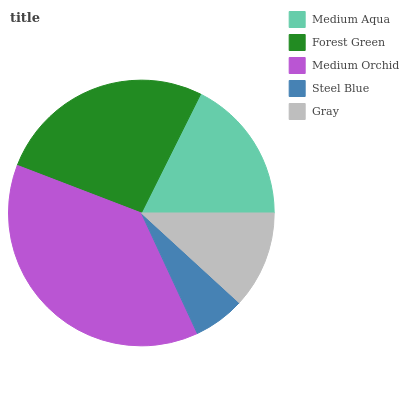Is Steel Blue the minimum?
Answer yes or no. Yes. Is Medium Orchid the maximum?
Answer yes or no. Yes. Is Forest Green the minimum?
Answer yes or no. No. Is Forest Green the maximum?
Answer yes or no. No. Is Forest Green greater than Medium Aqua?
Answer yes or no. Yes. Is Medium Aqua less than Forest Green?
Answer yes or no. Yes. Is Medium Aqua greater than Forest Green?
Answer yes or no. No. Is Forest Green less than Medium Aqua?
Answer yes or no. No. Is Medium Aqua the high median?
Answer yes or no. Yes. Is Medium Aqua the low median?
Answer yes or no. Yes. Is Steel Blue the high median?
Answer yes or no. No. Is Forest Green the low median?
Answer yes or no. No. 